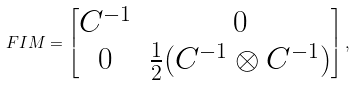<formula> <loc_0><loc_0><loc_500><loc_500>\ F I M = \begin{bmatrix} C ^ { - 1 } & 0 \\ 0 & \frac { 1 } { 2 } ( C ^ { - 1 } \otimes C ^ { - 1 } ) \end{bmatrix} ,</formula> 